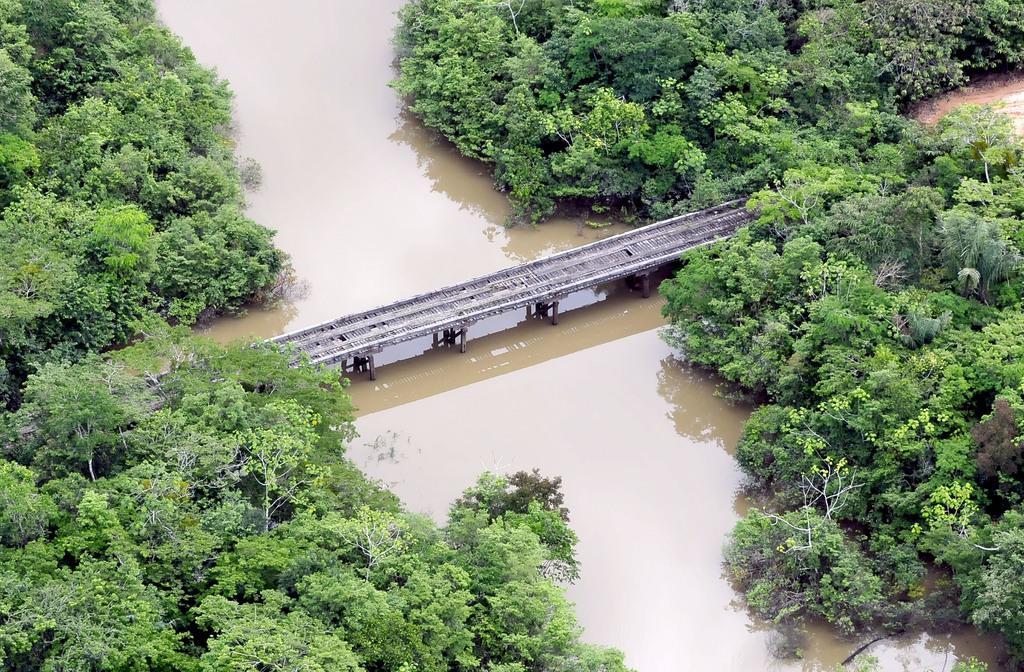In one or two sentences, can you explain what this image depicts? In the image there are a lot of plants and in between the plants there is a river and there is a wooden bridge constructed across the river. 